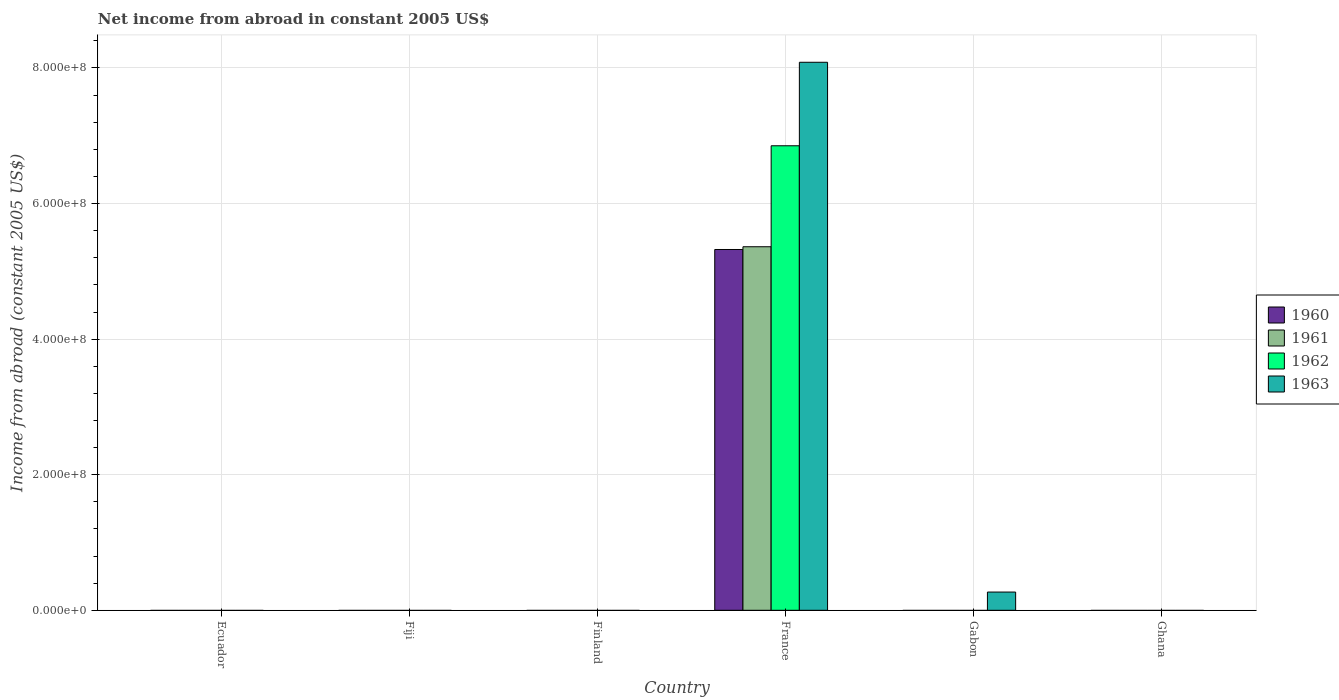Are the number of bars per tick equal to the number of legend labels?
Make the answer very short. No. Are the number of bars on each tick of the X-axis equal?
Offer a very short reply. No. What is the label of the 3rd group of bars from the left?
Provide a succinct answer. Finland. In how many cases, is the number of bars for a given country not equal to the number of legend labels?
Your answer should be compact. 5. What is the net income from abroad in 1963 in France?
Your response must be concise. 8.08e+08. Across all countries, what is the maximum net income from abroad in 1961?
Ensure brevity in your answer.  5.36e+08. In which country was the net income from abroad in 1963 maximum?
Provide a short and direct response. France. What is the total net income from abroad in 1961 in the graph?
Offer a very short reply. 5.36e+08. What is the average net income from abroad in 1960 per country?
Offer a very short reply. 8.87e+07. What is the difference between the net income from abroad of/in 1960 and net income from abroad of/in 1962 in France?
Ensure brevity in your answer.  -1.53e+08. What is the ratio of the net income from abroad in 1963 in France to that in Gabon?
Your response must be concise. 30.04. What is the difference between the highest and the lowest net income from abroad in 1963?
Make the answer very short. 8.08e+08. Is it the case that in every country, the sum of the net income from abroad in 1960 and net income from abroad in 1961 is greater than the sum of net income from abroad in 1962 and net income from abroad in 1963?
Ensure brevity in your answer.  No. Does the graph contain any zero values?
Your response must be concise. Yes. How are the legend labels stacked?
Provide a short and direct response. Vertical. What is the title of the graph?
Provide a succinct answer. Net income from abroad in constant 2005 US$. Does "1980" appear as one of the legend labels in the graph?
Offer a very short reply. No. What is the label or title of the X-axis?
Your answer should be compact. Country. What is the label or title of the Y-axis?
Offer a very short reply. Income from abroad (constant 2005 US$). What is the Income from abroad (constant 2005 US$) of 1961 in Ecuador?
Give a very brief answer. 0. What is the Income from abroad (constant 2005 US$) of 1962 in Ecuador?
Offer a terse response. 0. What is the Income from abroad (constant 2005 US$) of 1963 in Ecuador?
Keep it short and to the point. 0. What is the Income from abroad (constant 2005 US$) of 1960 in Fiji?
Provide a succinct answer. 0. What is the Income from abroad (constant 2005 US$) in 1961 in Fiji?
Ensure brevity in your answer.  0. What is the Income from abroad (constant 2005 US$) in 1962 in Fiji?
Your answer should be very brief. 0. What is the Income from abroad (constant 2005 US$) of 1960 in Finland?
Give a very brief answer. 0. What is the Income from abroad (constant 2005 US$) of 1961 in Finland?
Give a very brief answer. 0. What is the Income from abroad (constant 2005 US$) in 1963 in Finland?
Offer a terse response. 0. What is the Income from abroad (constant 2005 US$) in 1960 in France?
Provide a succinct answer. 5.32e+08. What is the Income from abroad (constant 2005 US$) in 1961 in France?
Your answer should be compact. 5.36e+08. What is the Income from abroad (constant 2005 US$) of 1962 in France?
Ensure brevity in your answer.  6.85e+08. What is the Income from abroad (constant 2005 US$) of 1963 in France?
Give a very brief answer. 8.08e+08. What is the Income from abroad (constant 2005 US$) of 1961 in Gabon?
Keep it short and to the point. 0. What is the Income from abroad (constant 2005 US$) in 1962 in Gabon?
Provide a succinct answer. 0. What is the Income from abroad (constant 2005 US$) in 1963 in Gabon?
Offer a terse response. 2.69e+07. What is the Income from abroad (constant 2005 US$) of 1961 in Ghana?
Provide a succinct answer. 0. What is the Income from abroad (constant 2005 US$) of 1963 in Ghana?
Keep it short and to the point. 0. Across all countries, what is the maximum Income from abroad (constant 2005 US$) in 1960?
Provide a short and direct response. 5.32e+08. Across all countries, what is the maximum Income from abroad (constant 2005 US$) in 1961?
Your answer should be compact. 5.36e+08. Across all countries, what is the maximum Income from abroad (constant 2005 US$) in 1962?
Give a very brief answer. 6.85e+08. Across all countries, what is the maximum Income from abroad (constant 2005 US$) of 1963?
Offer a very short reply. 8.08e+08. Across all countries, what is the minimum Income from abroad (constant 2005 US$) in 1961?
Offer a very short reply. 0. Across all countries, what is the minimum Income from abroad (constant 2005 US$) in 1963?
Your answer should be compact. 0. What is the total Income from abroad (constant 2005 US$) of 1960 in the graph?
Offer a terse response. 5.32e+08. What is the total Income from abroad (constant 2005 US$) of 1961 in the graph?
Offer a terse response. 5.36e+08. What is the total Income from abroad (constant 2005 US$) of 1962 in the graph?
Provide a succinct answer. 6.85e+08. What is the total Income from abroad (constant 2005 US$) of 1963 in the graph?
Make the answer very short. 8.35e+08. What is the difference between the Income from abroad (constant 2005 US$) in 1963 in France and that in Gabon?
Provide a succinct answer. 7.81e+08. What is the difference between the Income from abroad (constant 2005 US$) in 1960 in France and the Income from abroad (constant 2005 US$) in 1963 in Gabon?
Offer a very short reply. 5.05e+08. What is the difference between the Income from abroad (constant 2005 US$) of 1961 in France and the Income from abroad (constant 2005 US$) of 1963 in Gabon?
Offer a terse response. 5.09e+08. What is the difference between the Income from abroad (constant 2005 US$) of 1962 in France and the Income from abroad (constant 2005 US$) of 1963 in Gabon?
Provide a short and direct response. 6.58e+08. What is the average Income from abroad (constant 2005 US$) of 1960 per country?
Provide a succinct answer. 8.87e+07. What is the average Income from abroad (constant 2005 US$) of 1961 per country?
Your response must be concise. 8.94e+07. What is the average Income from abroad (constant 2005 US$) of 1962 per country?
Make the answer very short. 1.14e+08. What is the average Income from abroad (constant 2005 US$) in 1963 per country?
Keep it short and to the point. 1.39e+08. What is the difference between the Income from abroad (constant 2005 US$) in 1960 and Income from abroad (constant 2005 US$) in 1961 in France?
Provide a short and direct response. -4.05e+06. What is the difference between the Income from abroad (constant 2005 US$) in 1960 and Income from abroad (constant 2005 US$) in 1962 in France?
Offer a terse response. -1.53e+08. What is the difference between the Income from abroad (constant 2005 US$) in 1960 and Income from abroad (constant 2005 US$) in 1963 in France?
Ensure brevity in your answer.  -2.76e+08. What is the difference between the Income from abroad (constant 2005 US$) in 1961 and Income from abroad (constant 2005 US$) in 1962 in France?
Make the answer very short. -1.49e+08. What is the difference between the Income from abroad (constant 2005 US$) in 1961 and Income from abroad (constant 2005 US$) in 1963 in France?
Your response must be concise. -2.72e+08. What is the difference between the Income from abroad (constant 2005 US$) in 1962 and Income from abroad (constant 2005 US$) in 1963 in France?
Keep it short and to the point. -1.23e+08. What is the ratio of the Income from abroad (constant 2005 US$) in 1963 in France to that in Gabon?
Offer a terse response. 30.04. What is the difference between the highest and the lowest Income from abroad (constant 2005 US$) in 1960?
Provide a succinct answer. 5.32e+08. What is the difference between the highest and the lowest Income from abroad (constant 2005 US$) of 1961?
Ensure brevity in your answer.  5.36e+08. What is the difference between the highest and the lowest Income from abroad (constant 2005 US$) of 1962?
Your answer should be compact. 6.85e+08. What is the difference between the highest and the lowest Income from abroad (constant 2005 US$) in 1963?
Your response must be concise. 8.08e+08. 